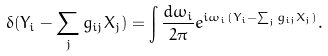<formula> <loc_0><loc_0><loc_500><loc_500>\delta ( Y _ { i } - \sum _ { j } g _ { i j } X _ { j } ) = \int \frac { d \omega _ { i } } { 2 \pi } e ^ { i \omega _ { i } ( Y _ { i } - \sum _ { j } g _ { i j } X _ { j } ) } .</formula> 